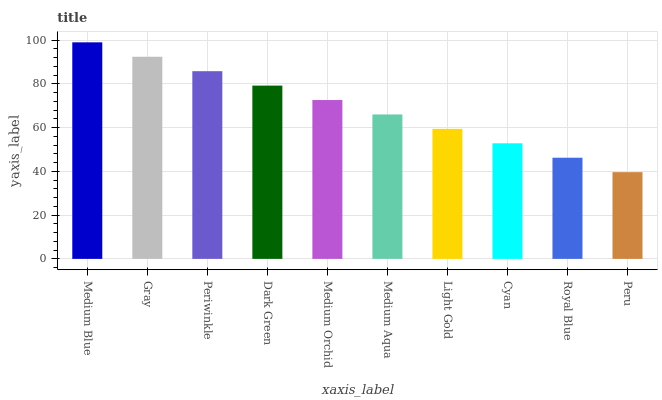Is Peru the minimum?
Answer yes or no. Yes. Is Medium Blue the maximum?
Answer yes or no. Yes. Is Gray the minimum?
Answer yes or no. No. Is Gray the maximum?
Answer yes or no. No. Is Medium Blue greater than Gray?
Answer yes or no. Yes. Is Gray less than Medium Blue?
Answer yes or no. Yes. Is Gray greater than Medium Blue?
Answer yes or no. No. Is Medium Blue less than Gray?
Answer yes or no. No. Is Medium Orchid the high median?
Answer yes or no. Yes. Is Medium Aqua the low median?
Answer yes or no. Yes. Is Royal Blue the high median?
Answer yes or no. No. Is Light Gold the low median?
Answer yes or no. No. 